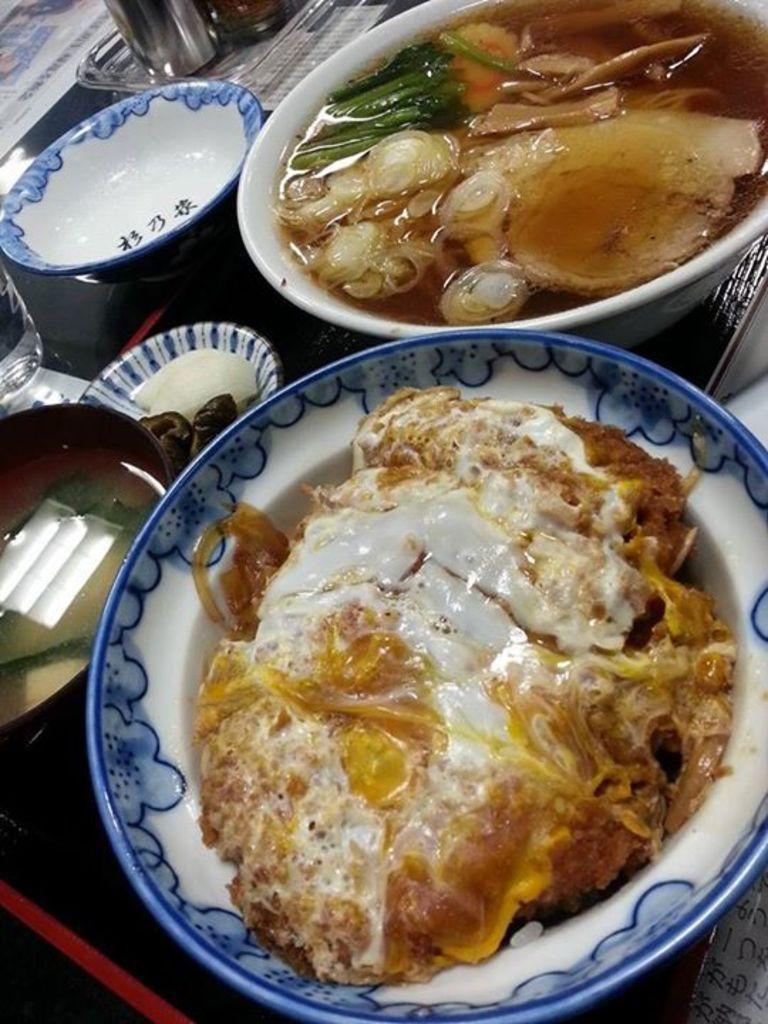Can you describe this image briefly? In this image we can see food items on the bowls, and plates, there is a glass, papers, and a bottle, which are on the table. 